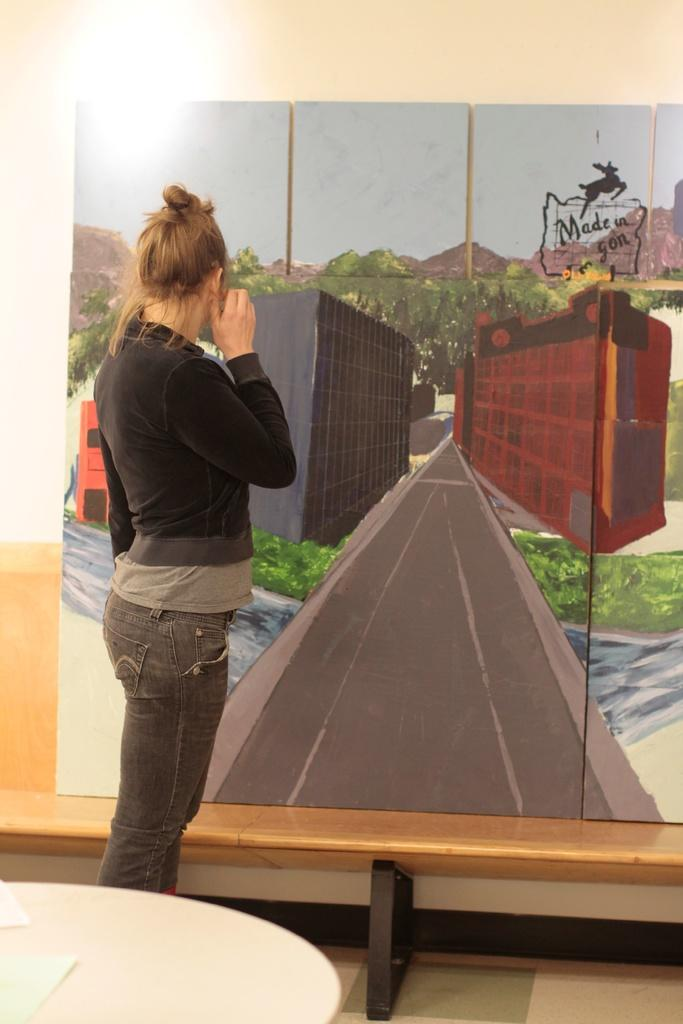What is the person in the room doing? The person is standing in the room and staring at a painting. Where is the person standing in the room? The person is standing on the floor. What furniture is present in the room? There is a table in the room. How would you describe the lighting in the room? The background of the room is light. Are there any kittens playing in the quicksand in the image? There are no kittens or quicksand present in the image. How many eggs can be seen on the table in the image? There is no mention of eggs in the image; the only furniture mentioned is a table. 